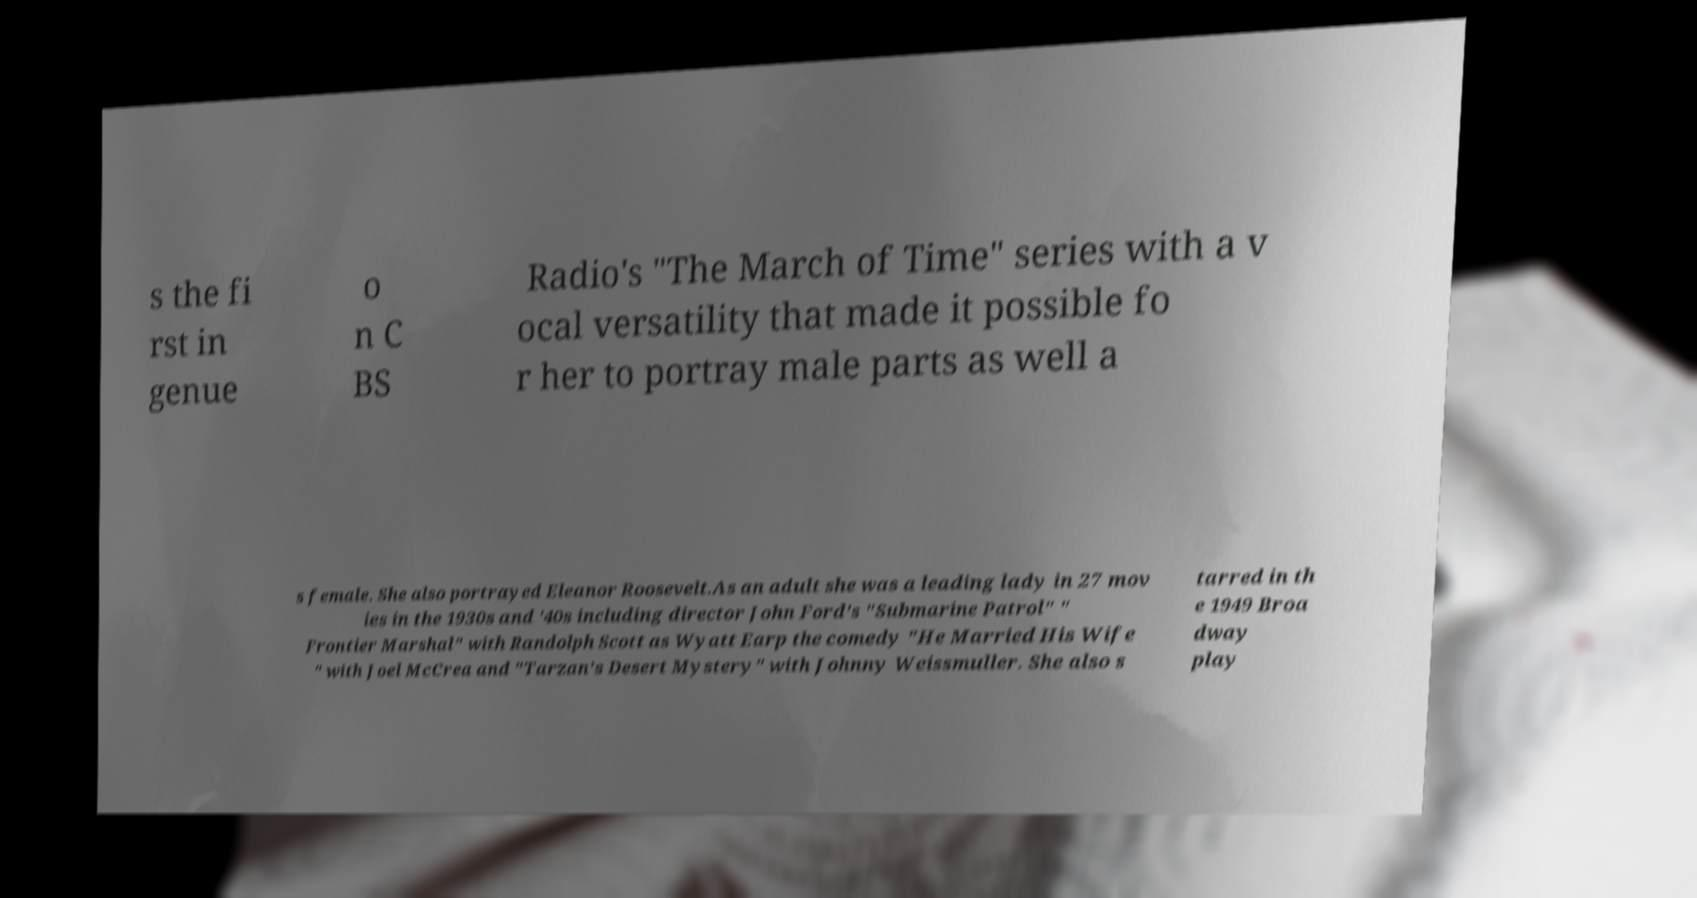For documentation purposes, I need the text within this image transcribed. Could you provide that? s the fi rst in genue o n C BS Radio's "The March of Time" series with a v ocal versatility that made it possible fo r her to portray male parts as well a s female. She also portrayed Eleanor Roosevelt.As an adult she was a leading lady in 27 mov ies in the 1930s and '40s including director John Ford's "Submarine Patrol" " Frontier Marshal" with Randolph Scott as Wyatt Earp the comedy "He Married His Wife " with Joel McCrea and "Tarzan's Desert Mystery" with Johnny Weissmuller. She also s tarred in th e 1949 Broa dway play 